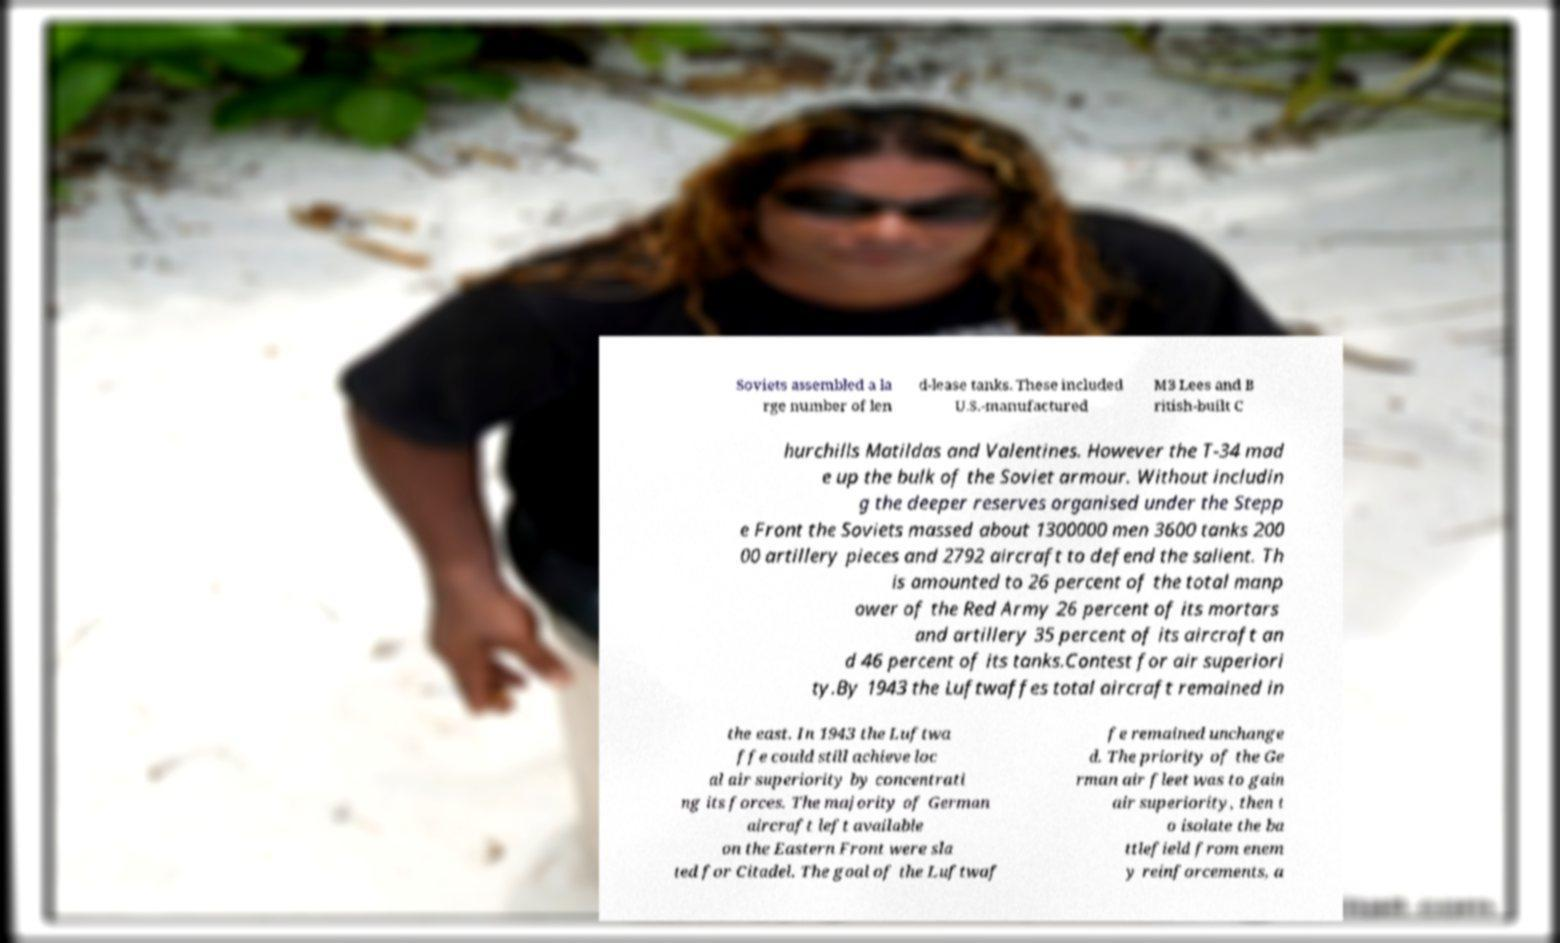For documentation purposes, I need the text within this image transcribed. Could you provide that? Soviets assembled a la rge number of len d-lease tanks. These included U.S.-manufactured M3 Lees and B ritish-built C hurchills Matildas and Valentines. However the T-34 mad e up the bulk of the Soviet armour. Without includin g the deeper reserves organised under the Stepp e Front the Soviets massed about 1300000 men 3600 tanks 200 00 artillery pieces and 2792 aircraft to defend the salient. Th is amounted to 26 percent of the total manp ower of the Red Army 26 percent of its mortars and artillery 35 percent of its aircraft an d 46 percent of its tanks.Contest for air superiori ty.By 1943 the Luftwaffes total aircraft remained in the east. In 1943 the Luftwa ffe could still achieve loc al air superiority by concentrati ng its forces. The majority of German aircraft left available on the Eastern Front were sla ted for Citadel. The goal of the Luftwaf fe remained unchange d. The priority of the Ge rman air fleet was to gain air superiority, then t o isolate the ba ttlefield from enem y reinforcements, a 